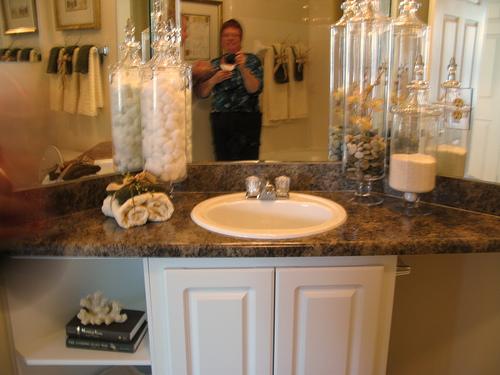Is there cotton balls on the sink?
Keep it brief. Yes. How many books are in the room?
Short answer required. 2. Is she taking a picture of herself?
Short answer required. Yes. 